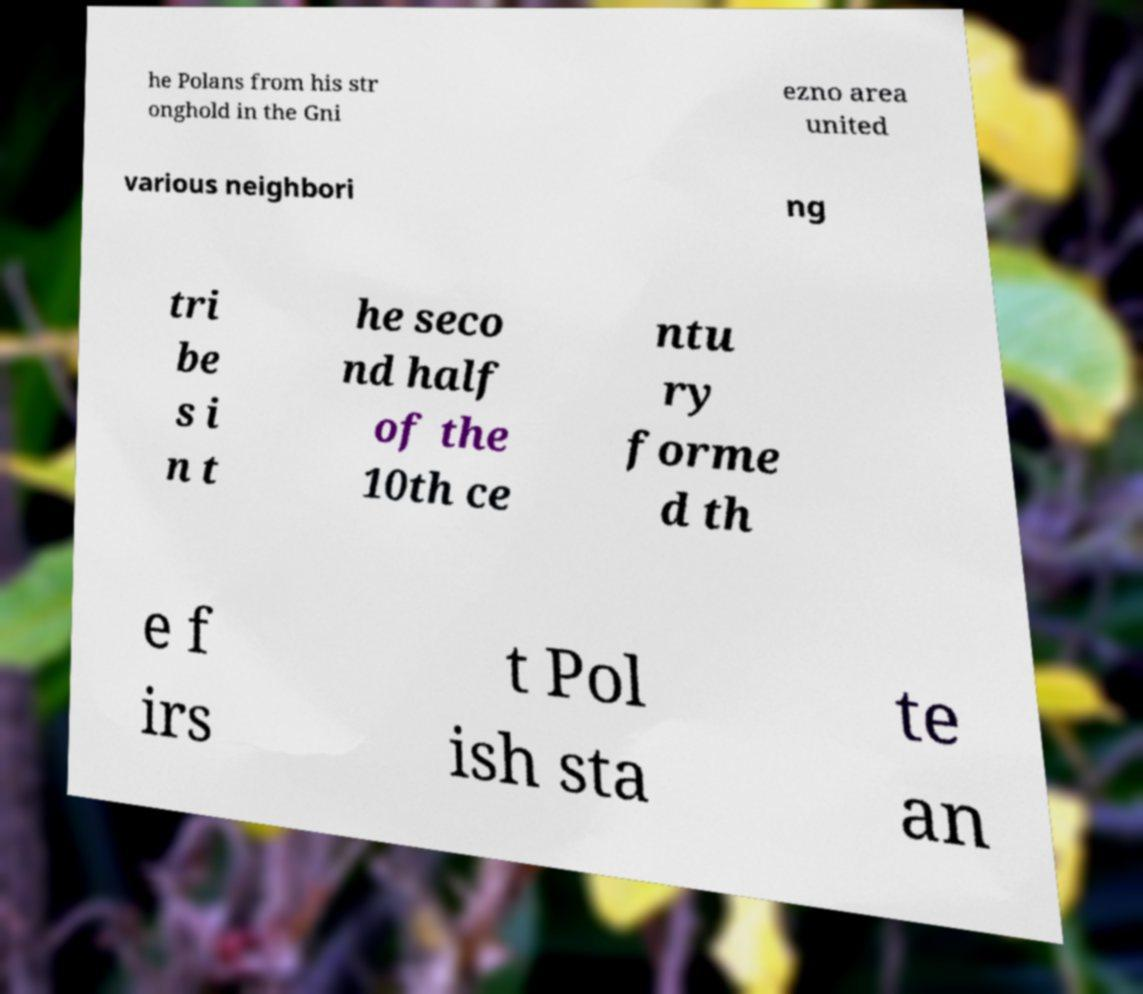I need the written content from this picture converted into text. Can you do that? he Polans from his str onghold in the Gni ezno area united various neighbori ng tri be s i n t he seco nd half of the 10th ce ntu ry forme d th e f irs t Pol ish sta te an 